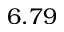<formula> <loc_0><loc_0><loc_500><loc_500>6 . 7 9</formula> 